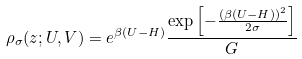<formula> <loc_0><loc_0><loc_500><loc_500>\rho _ { \sigma } ( z ; U , V ) = e ^ { \beta ( U - H ) } \frac { \exp \left [ - \frac { ( \beta ( U - H ) ) ^ { 2 } } { 2 \sigma } \right ] } { G }</formula> 